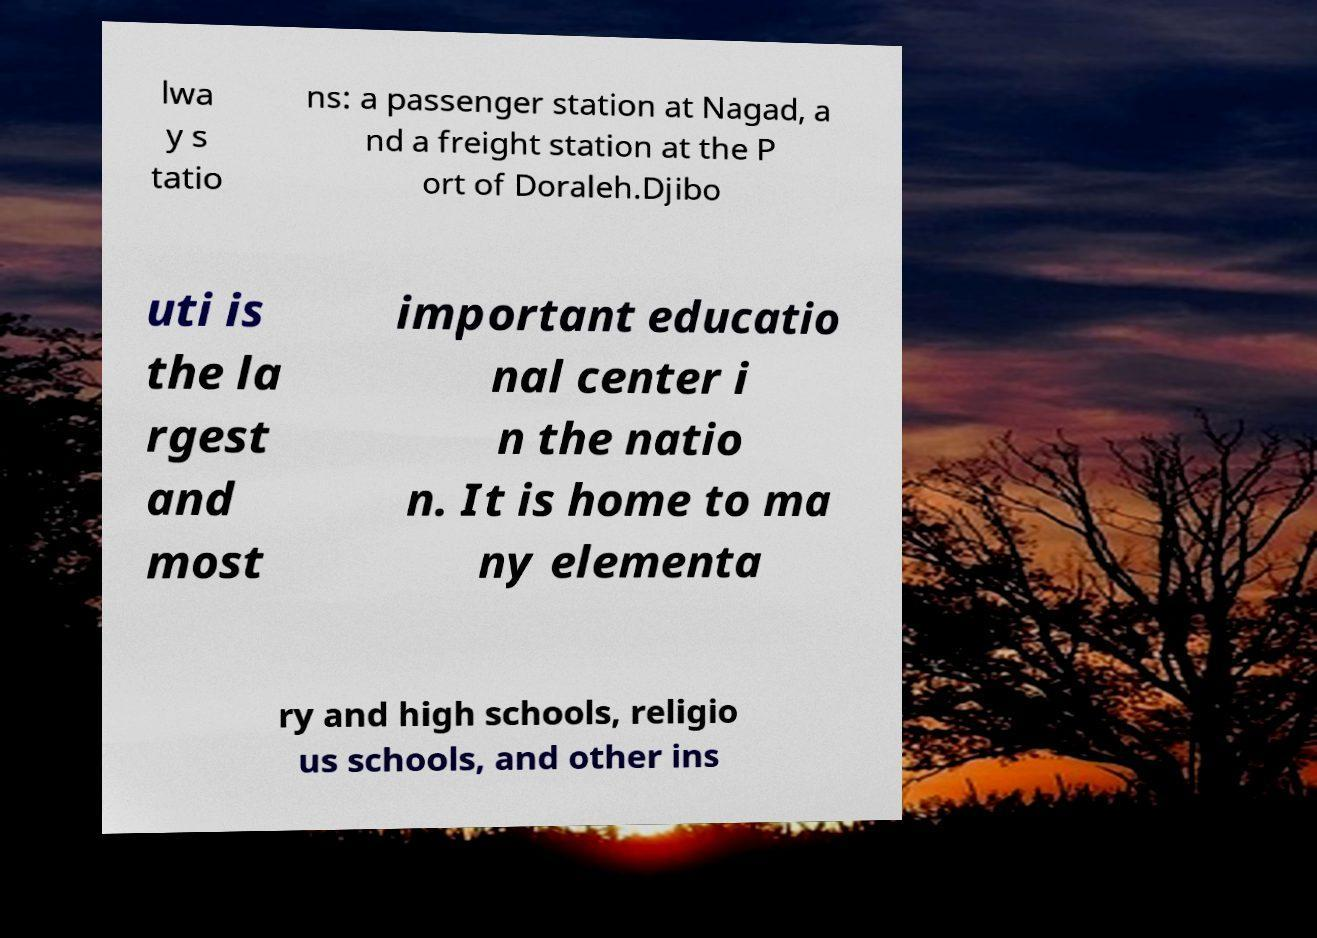Can you accurately transcribe the text from the provided image for me? lwa y s tatio ns: a passenger station at Nagad, a nd a freight station at the P ort of Doraleh.Djibo uti is the la rgest and most important educatio nal center i n the natio n. It is home to ma ny elementa ry and high schools, religio us schools, and other ins 